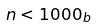<formula> <loc_0><loc_0><loc_500><loc_500>n < 1 0 0 0 _ { b }</formula> 